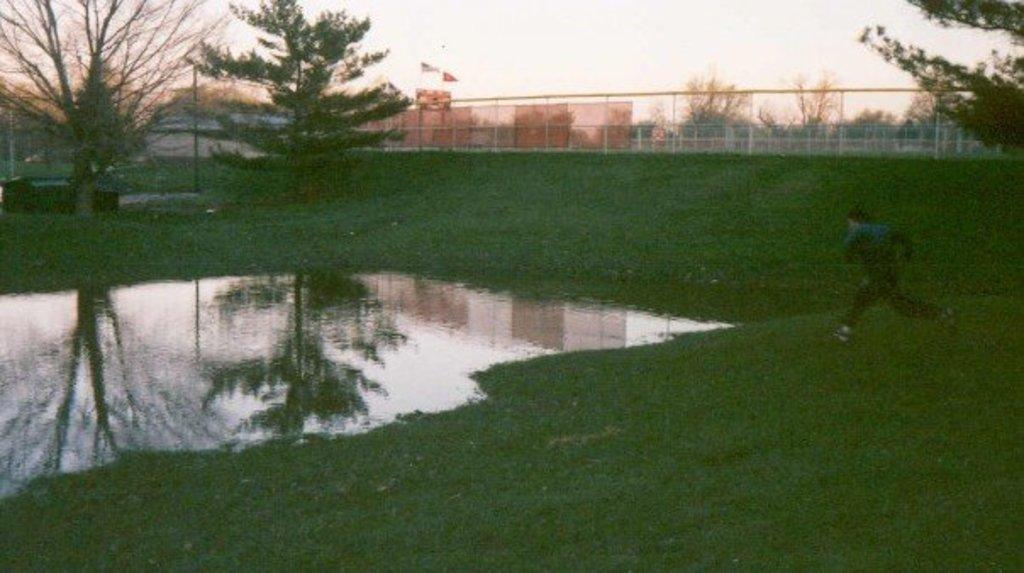Describe this image in one or two sentences. The picture is hazy. From the right a person is running. In the middle there is a water body. In the background trees, buildings, pole, sky. The place is surrounded by boundary. 